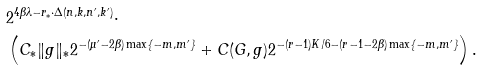Convert formula to latex. <formula><loc_0><loc_0><loc_500><loc_500>& 2 ^ { 4 \beta \lambda - r _ { * } \cdot \Delta ( n , k , n ^ { \prime } , k ^ { \prime } ) } \cdot \\ & \left ( C _ { * } \| g \| _ { * } 2 ^ { - ( \mu ^ { \prime } - 2 \beta ) \max \{ - m , m ^ { \prime } \} } + C ( G , g ) 2 ^ { - ( r - 1 ) K / 6 - ( r - 1 - 2 \beta ) \max \{ - m , m ^ { \prime } \} } \right ) .</formula> 